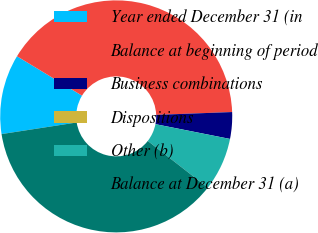Convert chart. <chart><loc_0><loc_0><loc_500><loc_500><pie_chart><fcel>Year ended December 31 (in<fcel>Balance at beginning of period<fcel>Business combinations<fcel>Dispositions<fcel>Other (b)<fcel>Balance at December 31 (a)<nl><fcel>11.11%<fcel>40.73%<fcel>3.71%<fcel>0.0%<fcel>7.41%<fcel>37.03%<nl></chart> 